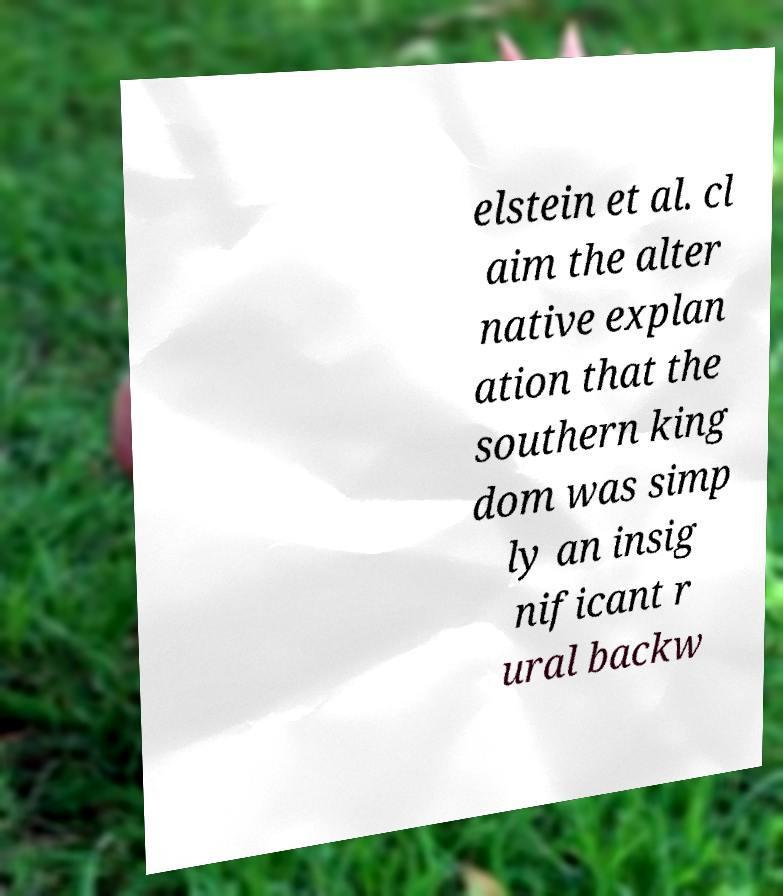What messages or text are displayed in this image? I need them in a readable, typed format. elstein et al. cl aim the alter native explan ation that the southern king dom was simp ly an insig nificant r ural backw 